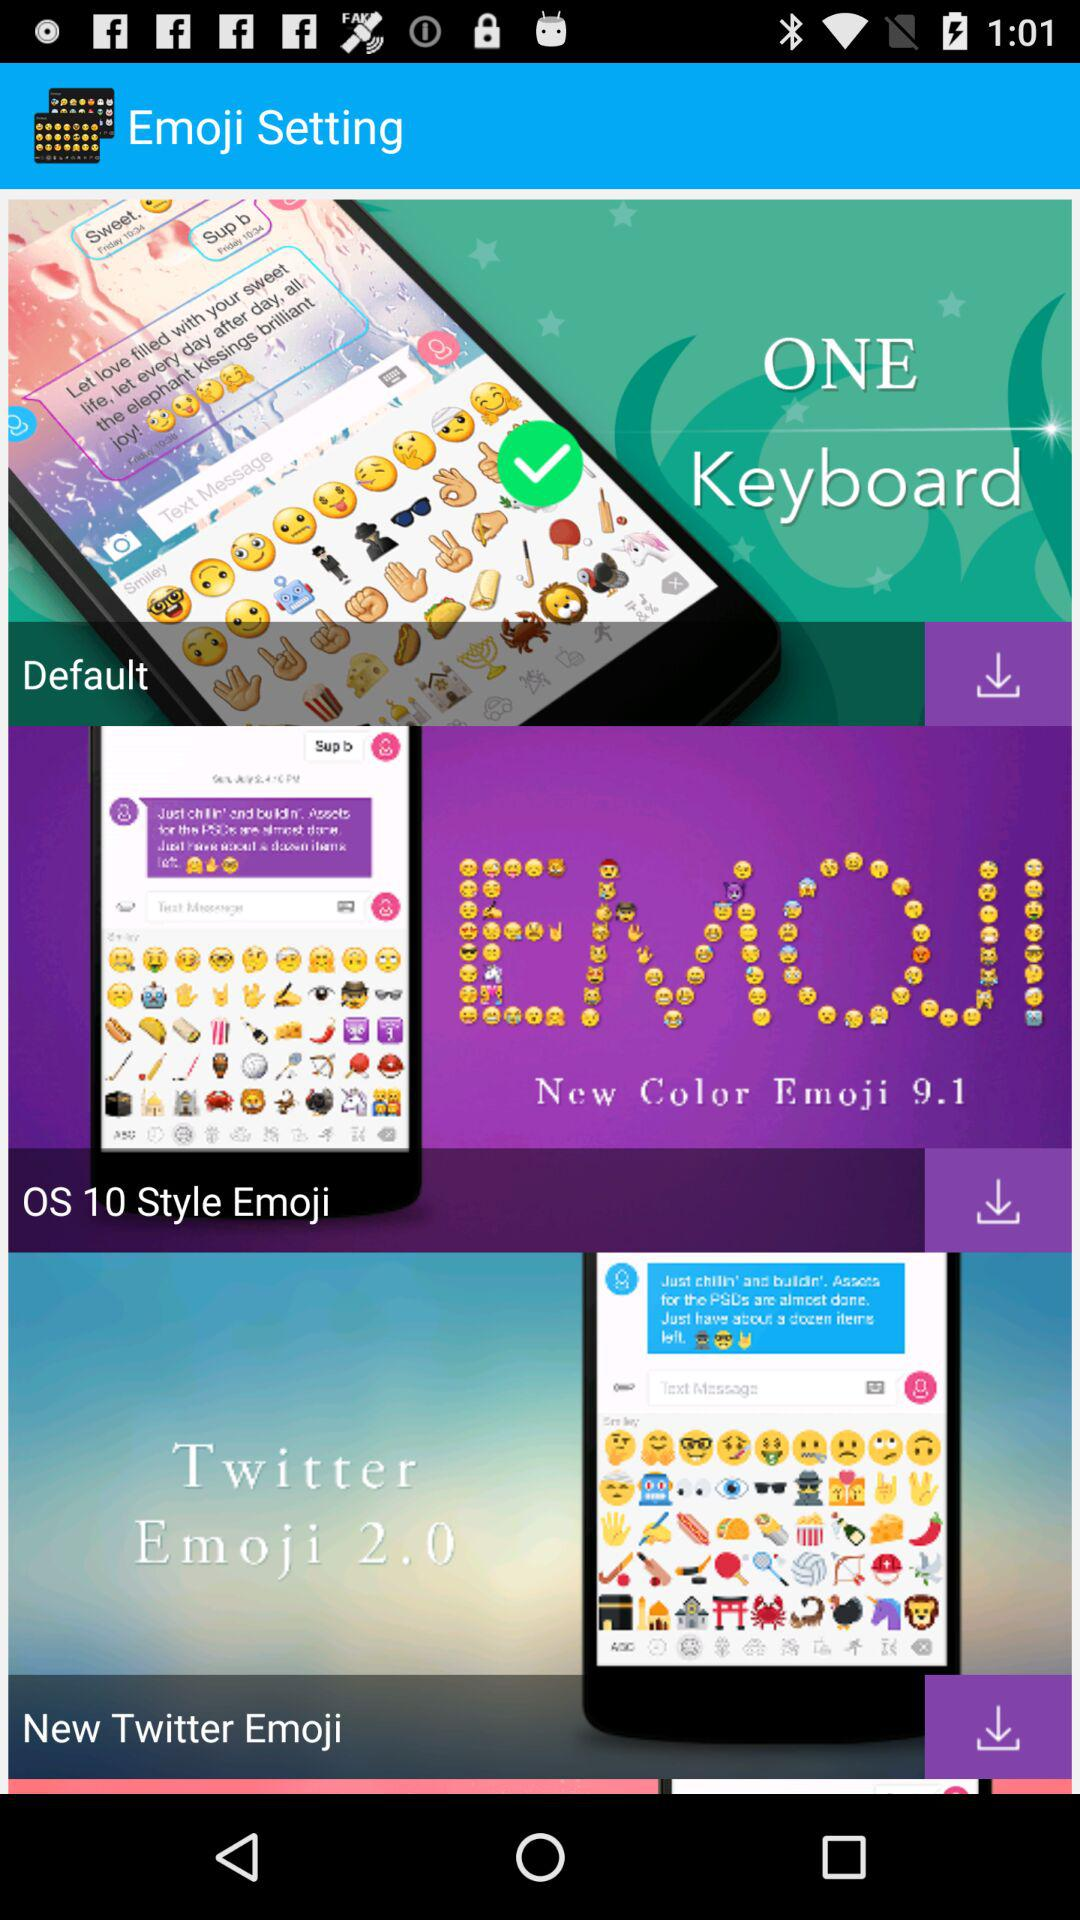How many emoji sets are available?
Answer the question using a single word or phrase. 3 